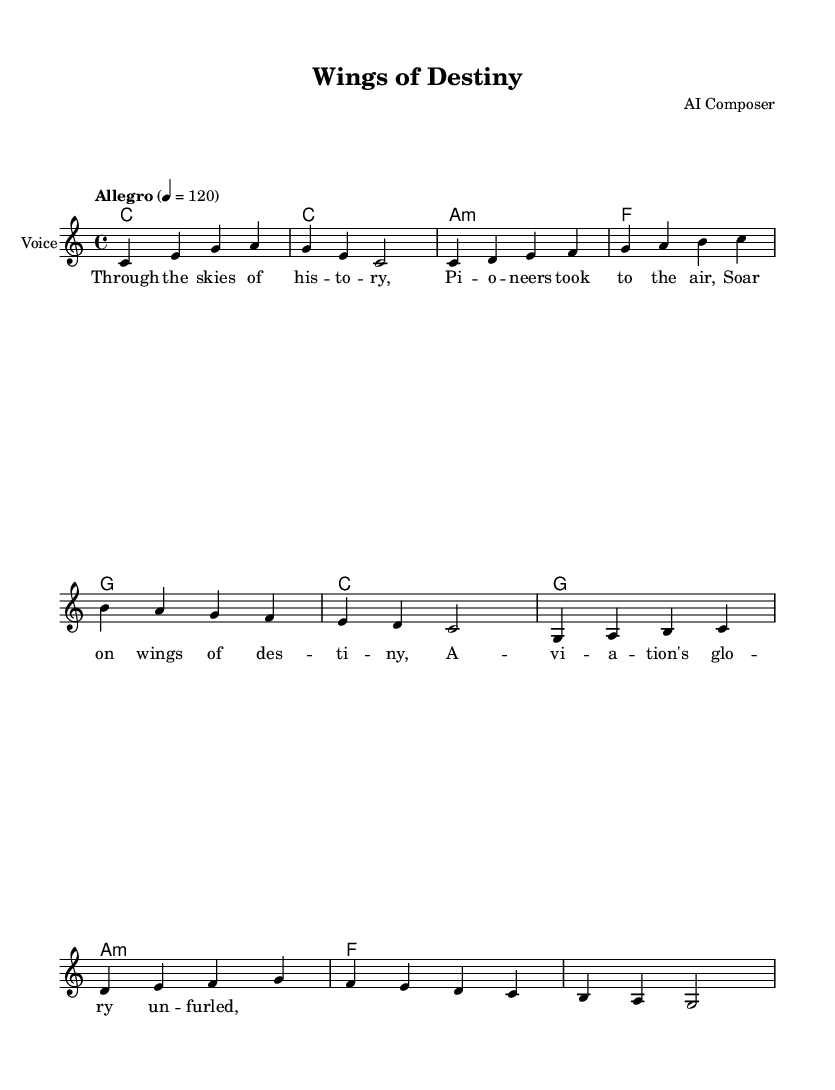What is the key signature of this music? The key signature indicates that this music is in C major, which is shown by the absence of any sharps or flats in the key signature line.
Answer: C major What is the time signature of this piece? The time signature is indicated by the numerals at the beginning of the staff. Here, it shows 4/4, meaning there are four beats in each measure, and a quarter note gets one beat.
Answer: 4/4 What is the tempo marking for this music? The tempo marking is specified at the start of the piece, which states "Allegro" at a speed of 120 beats per minute. This indicates a lively and fast tempo.
Answer: Allegro 4 = 120 How many measures are in the melody section? To determine the number of measures, we can count the individual groups of notes separated by vertical lines; there are a total of 6 measures in the melody section.
Answer: 6 What type of operatic theme is explored in this piece? The lyrics and overall theme suggest a focus on aviation, specifically the pioneers of flight and their achievements, which can be considered a celebration of aviation's history.
Answer: Aviation Which instrument is primarily featured in this sheet music? The sheet music indicates that the primary instrument featured is the voice, as denoted by the ‘Voice’ label in the staff section.
Answer: Voice 